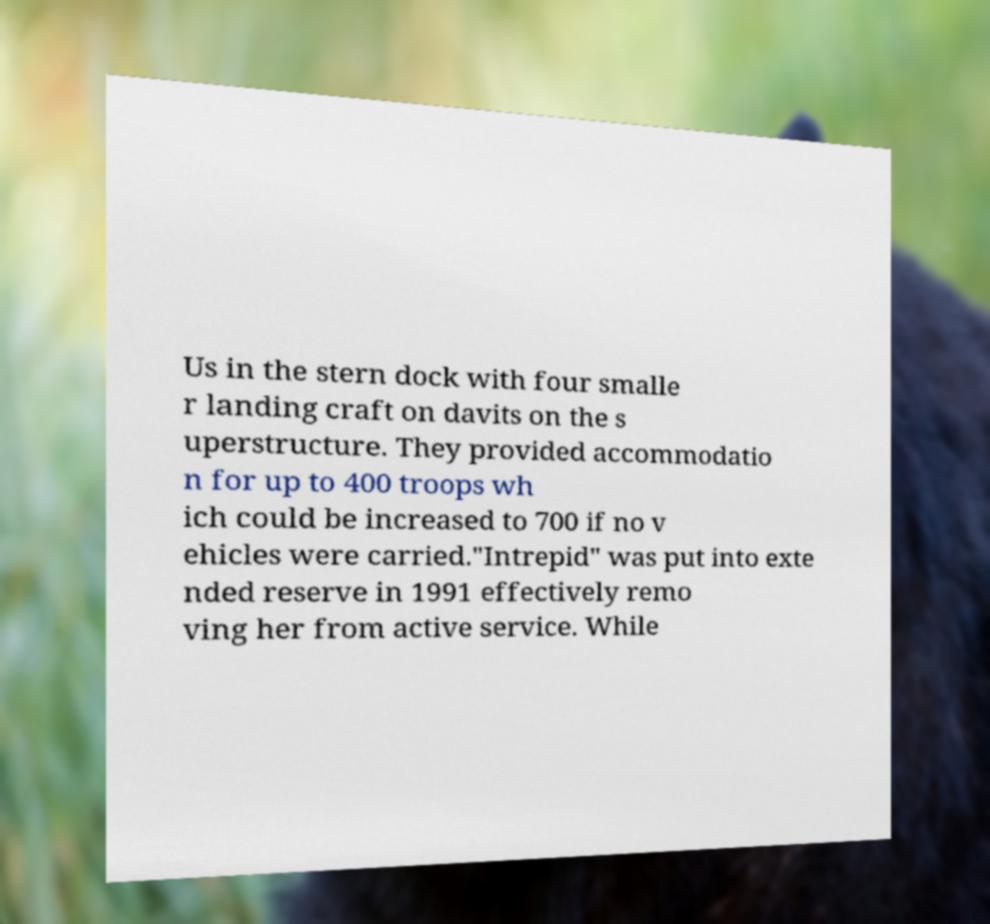Can you read and provide the text displayed in the image?This photo seems to have some interesting text. Can you extract and type it out for me? Us in the stern dock with four smalle r landing craft on davits on the s uperstructure. They provided accommodatio n for up to 400 troops wh ich could be increased to 700 if no v ehicles were carried."Intrepid" was put into exte nded reserve in 1991 effectively remo ving her from active service. While 